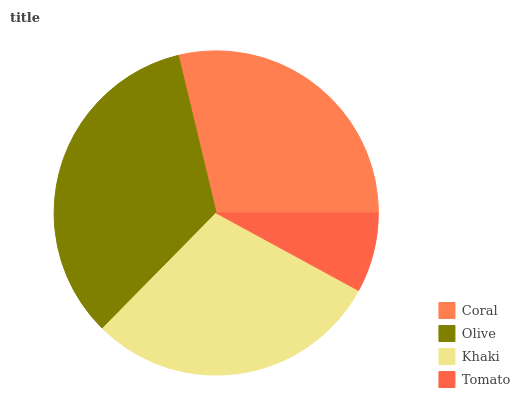Is Tomato the minimum?
Answer yes or no. Yes. Is Olive the maximum?
Answer yes or no. Yes. Is Khaki the minimum?
Answer yes or no. No. Is Khaki the maximum?
Answer yes or no. No. Is Olive greater than Khaki?
Answer yes or no. Yes. Is Khaki less than Olive?
Answer yes or no. Yes. Is Khaki greater than Olive?
Answer yes or no. No. Is Olive less than Khaki?
Answer yes or no. No. Is Khaki the high median?
Answer yes or no. Yes. Is Coral the low median?
Answer yes or no. Yes. Is Coral the high median?
Answer yes or no. No. Is Khaki the low median?
Answer yes or no. No. 